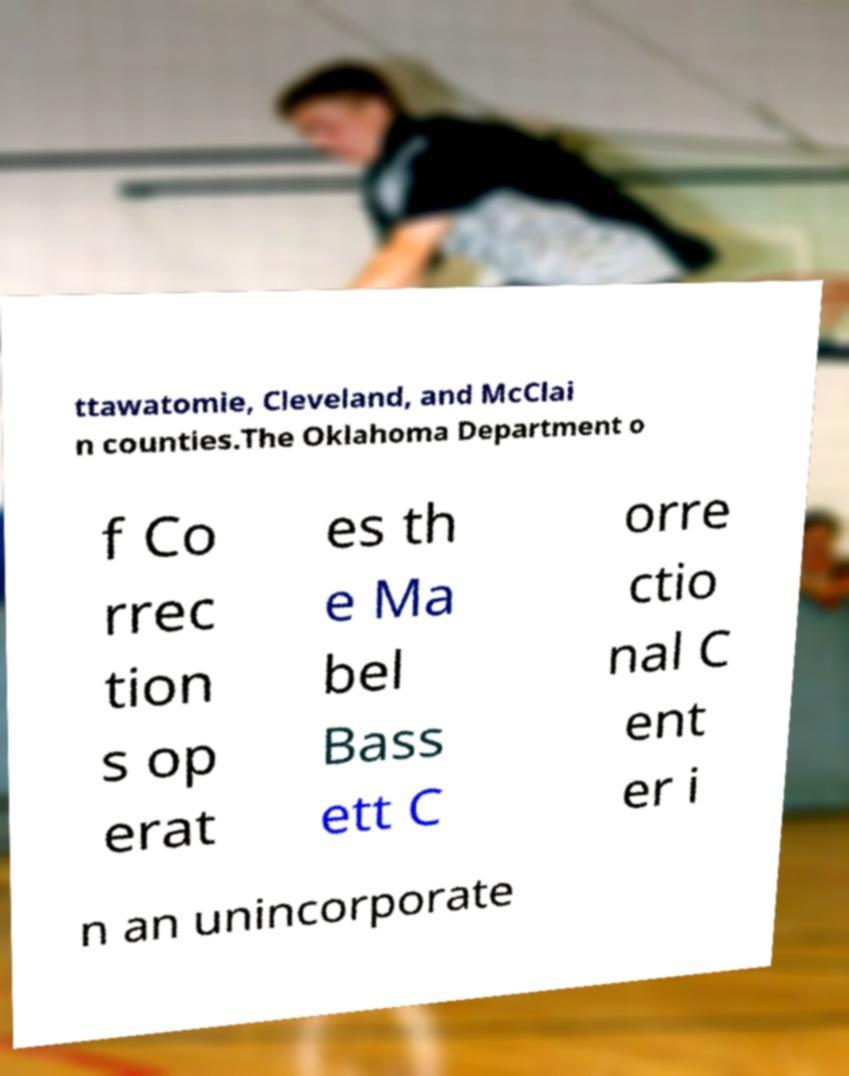Can you accurately transcribe the text from the provided image for me? ttawatomie, Cleveland, and McClai n counties.The Oklahoma Department o f Co rrec tion s op erat es th e Ma bel Bass ett C orre ctio nal C ent er i n an unincorporate 